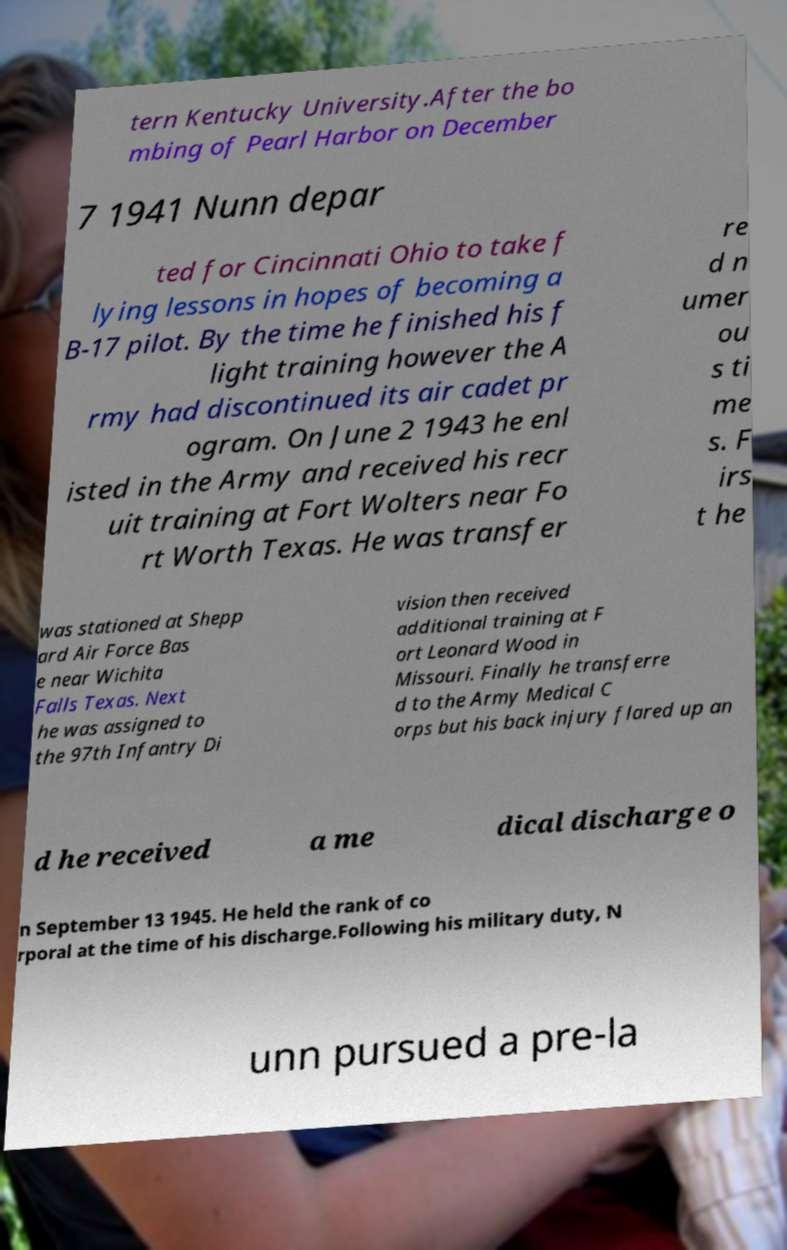Please identify and transcribe the text found in this image. tern Kentucky University.After the bo mbing of Pearl Harbor on December 7 1941 Nunn depar ted for Cincinnati Ohio to take f lying lessons in hopes of becoming a B-17 pilot. By the time he finished his f light training however the A rmy had discontinued its air cadet pr ogram. On June 2 1943 he enl isted in the Army and received his recr uit training at Fort Wolters near Fo rt Worth Texas. He was transfer re d n umer ou s ti me s. F irs t he was stationed at Shepp ard Air Force Bas e near Wichita Falls Texas. Next he was assigned to the 97th Infantry Di vision then received additional training at F ort Leonard Wood in Missouri. Finally he transferre d to the Army Medical C orps but his back injury flared up an d he received a me dical discharge o n September 13 1945. He held the rank of co rporal at the time of his discharge.Following his military duty, N unn pursued a pre-la 